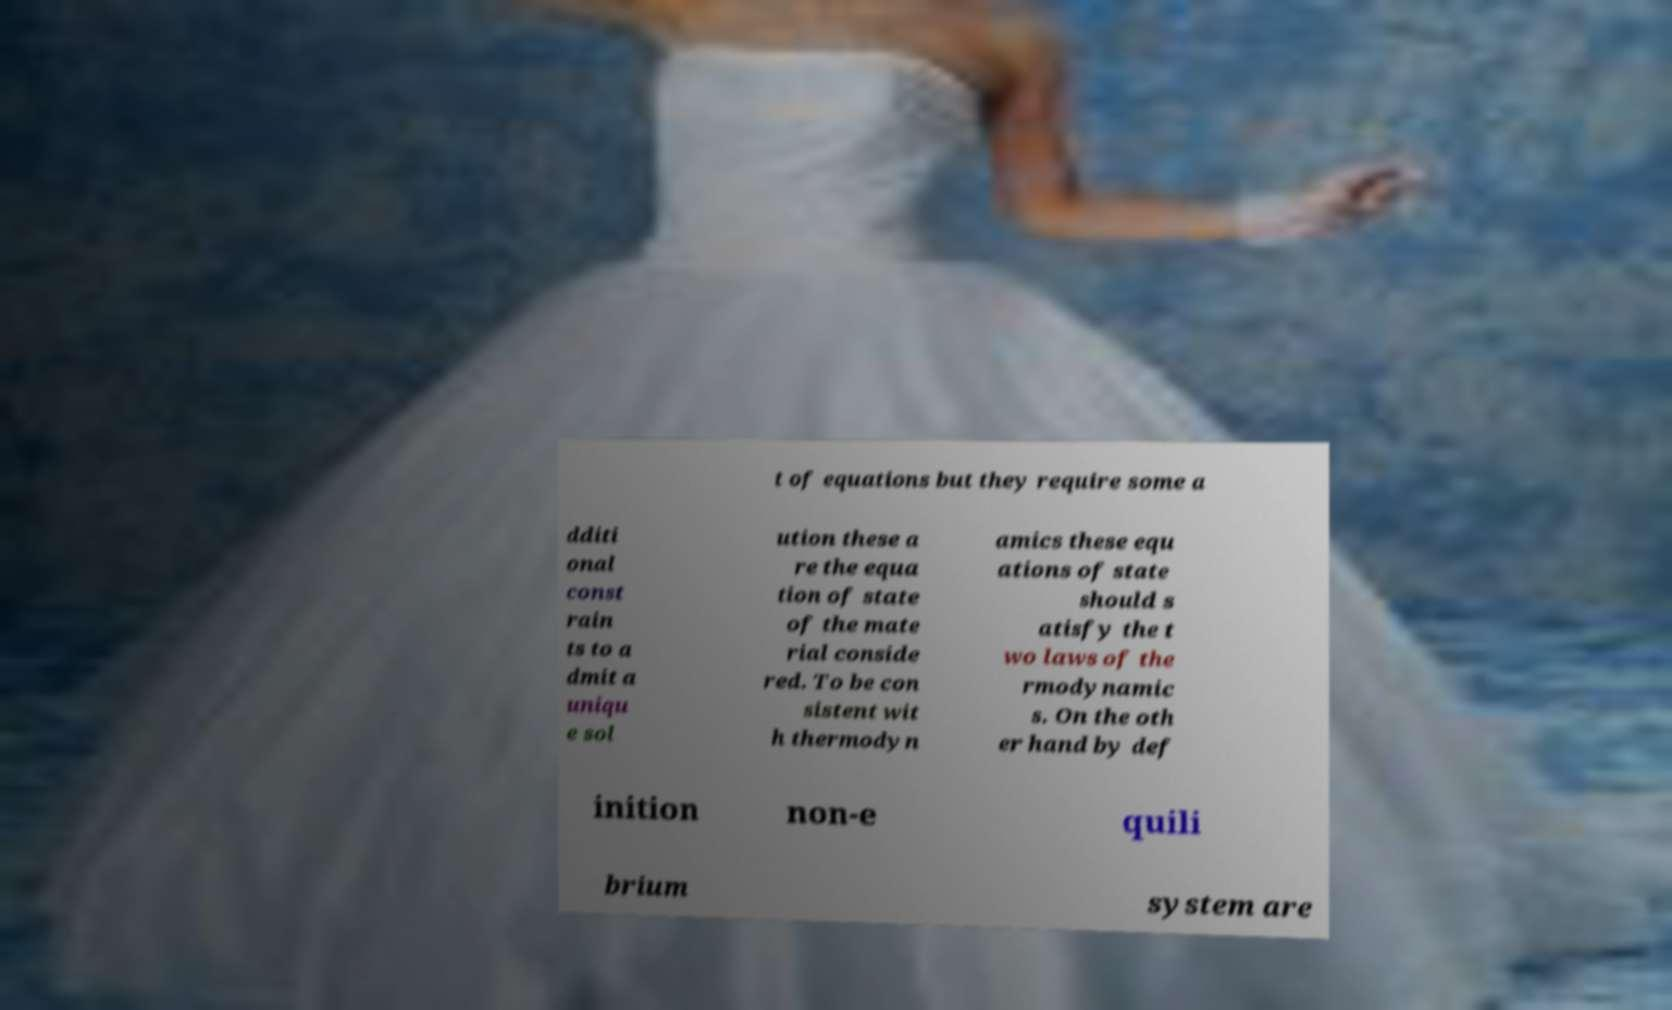Can you accurately transcribe the text from the provided image for me? t of equations but they require some a dditi onal const rain ts to a dmit a uniqu e sol ution these a re the equa tion of state of the mate rial conside red. To be con sistent wit h thermodyn amics these equ ations of state should s atisfy the t wo laws of the rmodynamic s. On the oth er hand by def inition non-e quili brium system are 